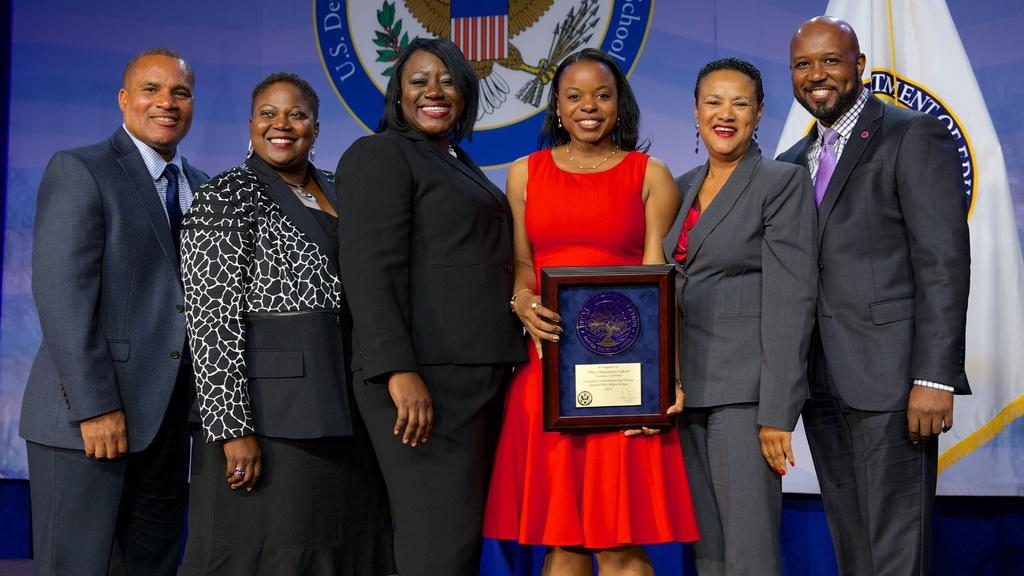What are the people in the image doing? The people in the image are standing and smiling. Can you describe any objects that the people are holding? One person is holding a frame. What can be seen in the background of the image? There is a flag and a banner in the background. How many toys can be seen on the people's chins in the image? There are no toys visible on the people's chins in the image. What color are the people's toes in the image? There is no information about the color of the people's toes in the image. 